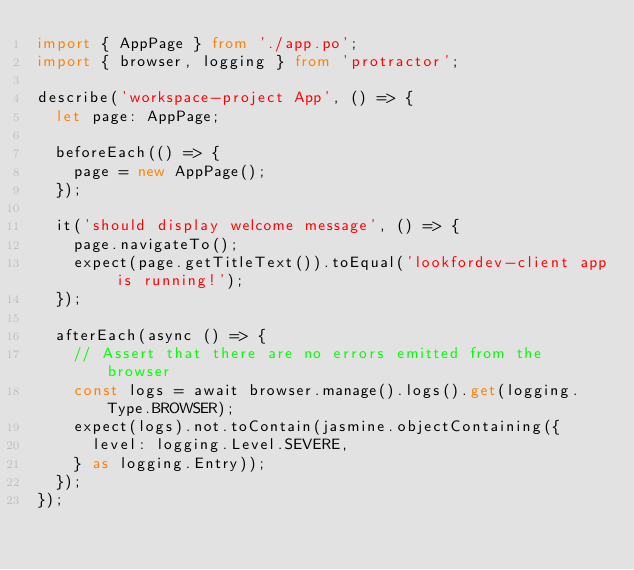Convert code to text. <code><loc_0><loc_0><loc_500><loc_500><_TypeScript_>import { AppPage } from './app.po';
import { browser, logging } from 'protractor';

describe('workspace-project App', () => {
  let page: AppPage;

  beforeEach(() => {
    page = new AppPage();
  });

  it('should display welcome message', () => {
    page.navigateTo();
    expect(page.getTitleText()).toEqual('lookfordev-client app is running!');
  });

  afterEach(async () => {
    // Assert that there are no errors emitted from the browser
    const logs = await browser.manage().logs().get(logging.Type.BROWSER);
    expect(logs).not.toContain(jasmine.objectContaining({
      level: logging.Level.SEVERE,
    } as logging.Entry));
  });
});
</code> 